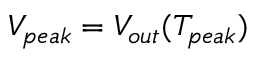<formula> <loc_0><loc_0><loc_500><loc_500>V _ { p e a k } = V _ { o u t } ( T _ { p e a k } )</formula> 